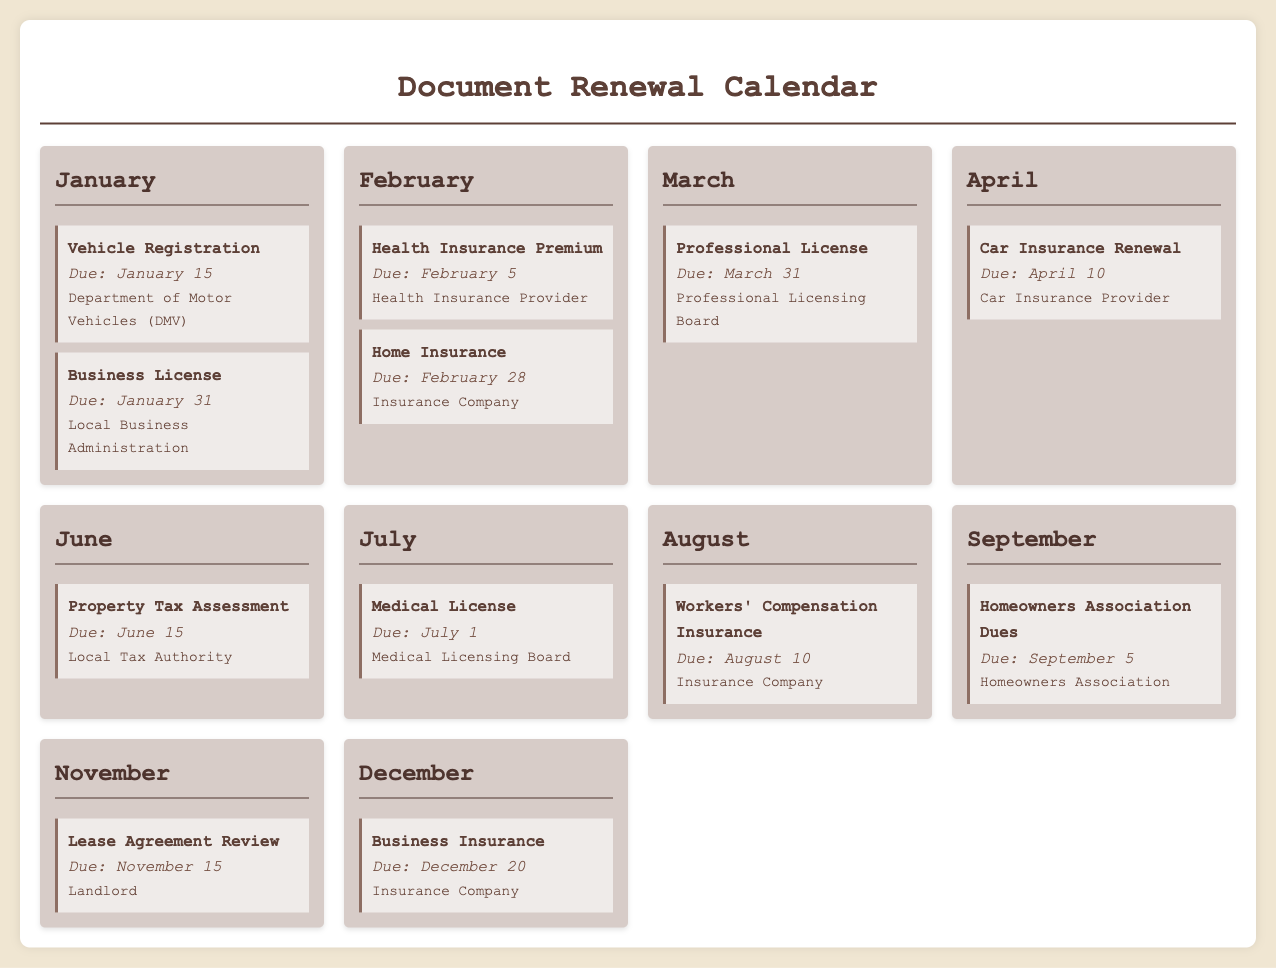What is the renewal date for Vehicle Registration? The renewal date for Vehicle Registration is listed in January and is due on January 15.
Answer: January 15 Which entity is responsible for the Homeowners Association Dues? The Homeowners Association Dues are associated with the Homeowners Association, which is mentioned in the September section.
Answer: Homeowners Association How many renewal types are mentioned for the month of February? In February, there are two renewal types listed: Health Insurance Premium and Home Insurance.
Answer: 2 What is the due date for the Business License? The due date for the Business License is found in January, and it is mentioned to be due on January 31.
Answer: January 31 Which insurance policy is due in April? In April, the Car Insurance Renewal is the mentioned insurance policy due on April 10.
Answer: Car Insurance Renewal What type of license is due on July 1? The document states that the Medical License is due on July 1.
Answer: Medical License What is the last renewal date listed in the calendar? The last renewal date mentioned in the calendar is for Business Insurance, which is due on December 20.
Answer: December 20 Which renewal is due on March 31? The Professional License is due on March 31 as stated in the March section.
Answer: Professional License How many months have insurance renewals listed? Insurance renewals are noted in February, April, August, and December, totaling four months.
Answer: 4 